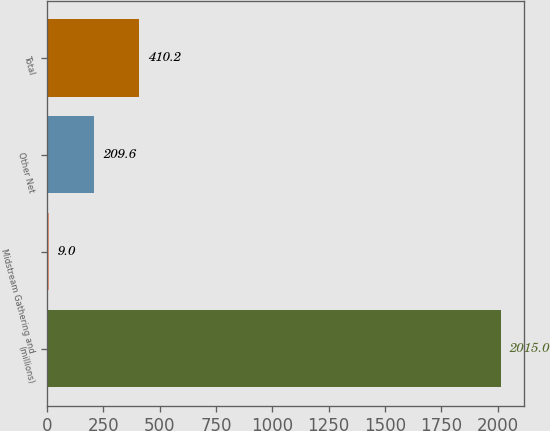Convert chart to OTSL. <chart><loc_0><loc_0><loc_500><loc_500><bar_chart><fcel>(millions)<fcel>Midstream Gathering and<fcel>Other Net<fcel>Total<nl><fcel>2015<fcel>9<fcel>209.6<fcel>410.2<nl></chart> 